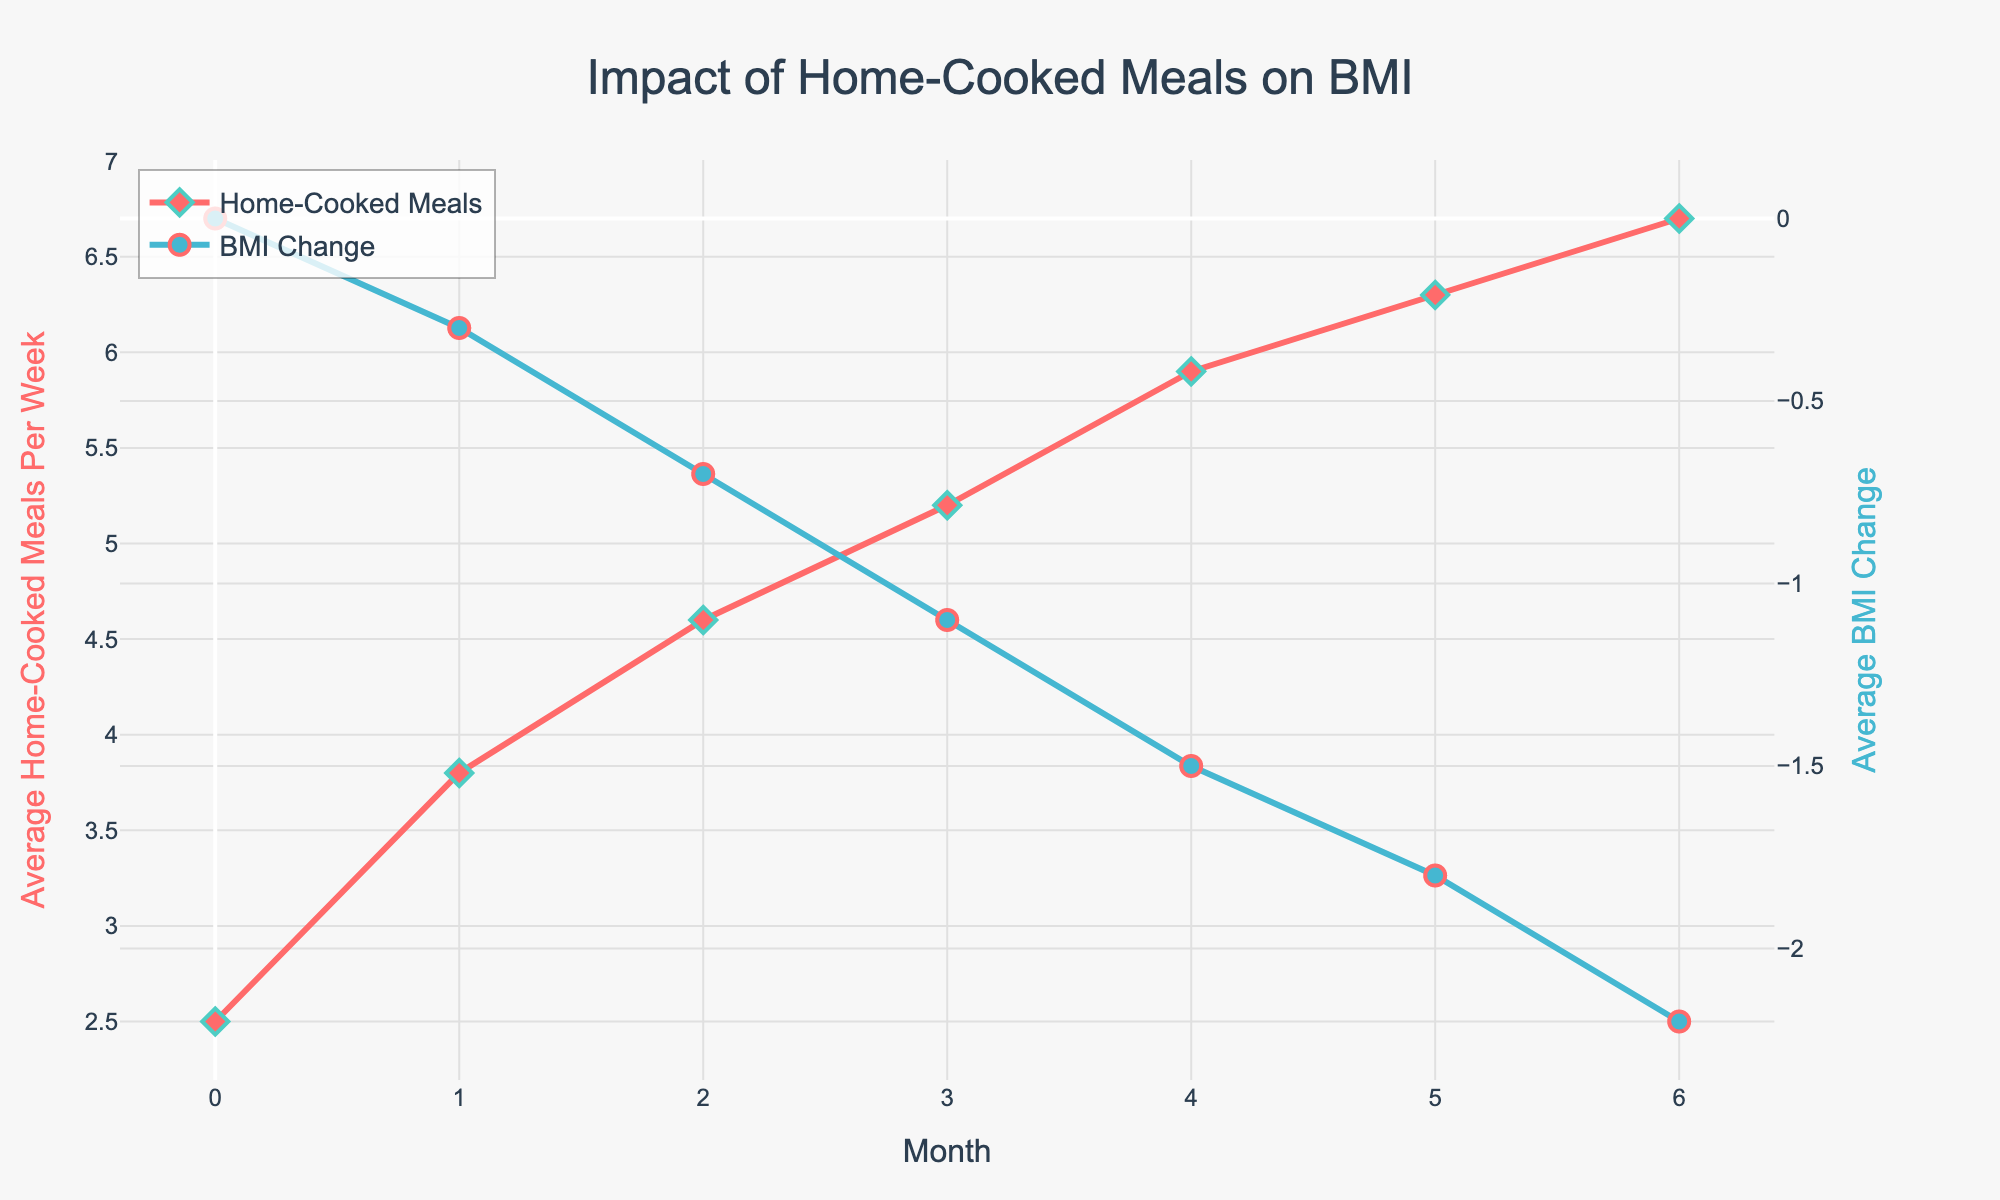Which month shows the highest number of average home-cooked meals per week? Look for the peak in the red line representing home-cooked meals. The highest point is at month 6 with 6.7 meals per week.
Answer: Month 6 Between months 1 and 5, during which month does the largest decrease in BMI occur? Look at the blue line representing BMI change, and observe the largest drop between months 3 to 4, where the change is -0.4 units.
Answer: Month 4 How much did the average BMI change between month 0 and month 6? Compare the BMI change at month 0 and month 6. At month 0 it is 0.0, and at month 6 it is -2.2. The difference is 2.2 units.
Answer: 2.2 units What can be inferred about the relationship between home-cooked meals and BMI over the 6 months? As the frequency of home-cooked meals increases (red line goes up), the BMI decreases (blue line goes down). This indicates a negative correlation between the two.
Answer: Negative correlation How many additional home-cooked meals per week were there on average at month 6 compared to month 0? At month 0, the average is 2.5, and at month 6, it is 6.7. Subtract 2.5 from 6.7 to find the difference, which is 4.2 meals.
Answer: 4.2 meals What is the average number of home-cooked meals per week over the 6-month period? Sum the average meals per week for each month: 2.5 + 3.8 + 4.6 + 5.2 + 5.9 + 6.3 + 6.7 = 35. Multiply by number of months 7 to get 35 / 7 = 5 per week.
Answer: 5 meals per week Does the BMI change ever plateau during the 6-month period? Check if the blue line ever flattens. It only continually decreases, indicating no plateau.
Answer: No Between which consecutive months is the smallest change in the average number of home-cooked meals observed? Compare the difference month by month for the red line. The smallest change is between months 5 and 6 (0.4 increase).
Answer: Month 5 to 6 Is there a month where the BMI change does not continue to decrease? Look for any non-decreasing, upward, or flat segment in the blue line; there is none, so BMI continually decreases.
Answer: No How does the trend in BMI change visually compare to the trend in home-cooked meals? The red line (meals) trends upward while the blue line (BMI) trends downward, indicating an inverse relationship.
Answer: Inverse relationship 